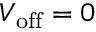<formula> <loc_0><loc_0><loc_500><loc_500>V _ { o f f } = 0</formula> 